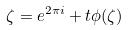Convert formula to latex. <formula><loc_0><loc_0><loc_500><loc_500>\zeta = e ^ { 2 \pi i } + t \phi ( \zeta )</formula> 